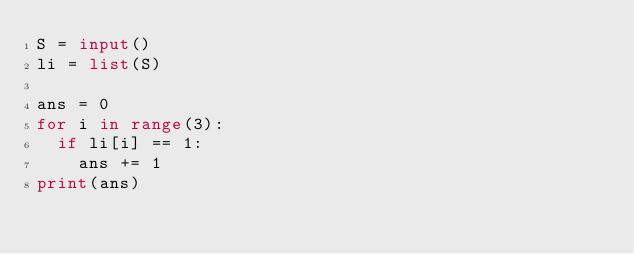<code> <loc_0><loc_0><loc_500><loc_500><_Python_>S = input()
li = list(S)

ans = 0
for i in range(3):
  if li[i] == 1:
    ans += 1
print(ans)</code> 